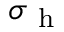Convert formula to latex. <formula><loc_0><loc_0><loc_500><loc_500>\sigma _ { h }</formula> 